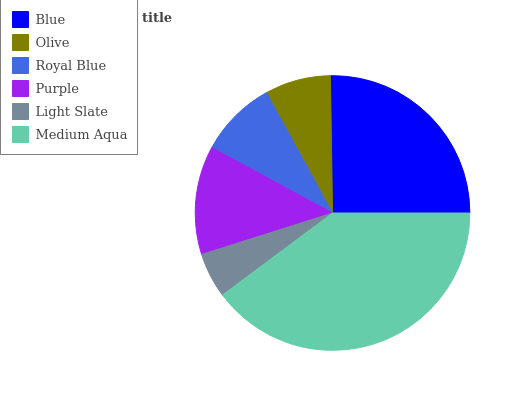Is Light Slate the minimum?
Answer yes or no. Yes. Is Medium Aqua the maximum?
Answer yes or no. Yes. Is Olive the minimum?
Answer yes or no. No. Is Olive the maximum?
Answer yes or no. No. Is Blue greater than Olive?
Answer yes or no. Yes. Is Olive less than Blue?
Answer yes or no. Yes. Is Olive greater than Blue?
Answer yes or no. No. Is Blue less than Olive?
Answer yes or no. No. Is Purple the high median?
Answer yes or no. Yes. Is Royal Blue the low median?
Answer yes or no. Yes. Is Medium Aqua the high median?
Answer yes or no. No. Is Olive the low median?
Answer yes or no. No. 